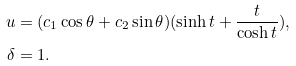Convert formula to latex. <formula><loc_0><loc_0><loc_500><loc_500>u & = ( c _ { 1 } \cos \theta + c _ { 2 } \sin { \theta } ) ( \sinh { t } + \frac { t } { \cosh { t } } ) , \\ \delta & = 1 .</formula> 